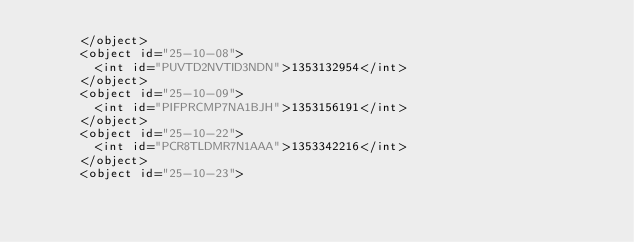Convert code to text. <code><loc_0><loc_0><loc_500><loc_500><_XML_>			</object>
			<object id="25-10-08">
				<int id="PUVTD2NVTID3NDN">1353132954</int>
			</object>
			<object id="25-10-09">
				<int id="PIFPRCMP7NA1BJH">1353156191</int>
			</object>
			<object id="25-10-22">
				<int id="PCR8TLDMR7N1AAA">1353342216</int>
			</object>
			<object id="25-10-23"></code> 